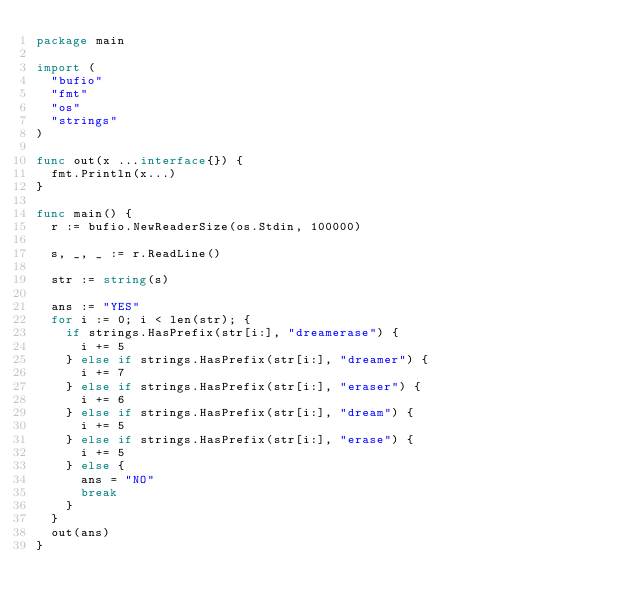<code> <loc_0><loc_0><loc_500><loc_500><_Go_>package main

import (
	"bufio"
	"fmt"
	"os"
	"strings"
)

func out(x ...interface{}) {
	fmt.Println(x...)
}

func main() {
	r := bufio.NewReaderSize(os.Stdin, 100000)

	s, _, _ := r.ReadLine()

	str := string(s)

	ans := "YES"
	for i := 0; i < len(str); {
		if strings.HasPrefix(str[i:], "dreamerase") {
			i += 5
		} else if strings.HasPrefix(str[i:], "dreamer") {
			i += 7
		} else if strings.HasPrefix(str[i:], "eraser") {
			i += 6
		} else if strings.HasPrefix(str[i:], "dream") {
			i += 5
		} else if strings.HasPrefix(str[i:], "erase") {
			i += 5
		} else {
			ans = "NO"
			break
		}
	}
	out(ans)
}
</code> 